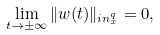<formula> <loc_0><loc_0><loc_500><loc_500>\lim _ { t \rightarrow \pm \infty } \| w ( t ) \| _ { \L i n ^ { q } _ { x } } = 0 ,</formula> 